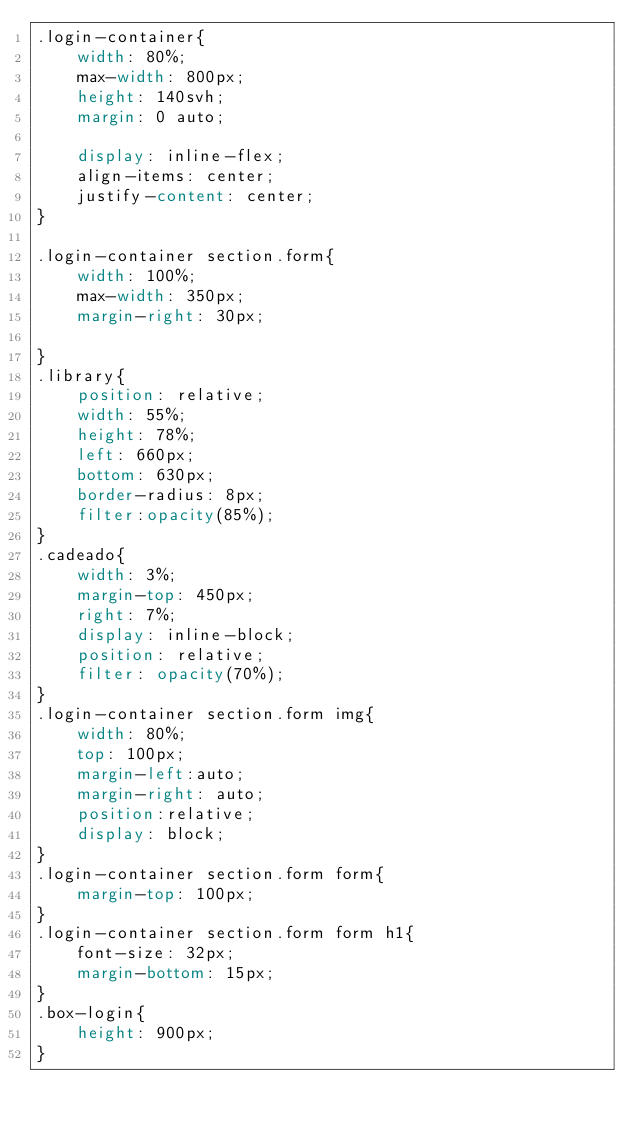<code> <loc_0><loc_0><loc_500><loc_500><_CSS_>.login-container{
    width: 80%;
    max-width: 800px;
    height: 140svh;
    margin: 0 auto;

    display: inline-flex;
    align-items: center;
    justify-content: center;
}

.login-container section.form{
    width: 100%;
    max-width: 350px;
    margin-right: 30px;

}
.library{
    position: relative;
    width: 55%;
    height: 78%;
    left: 660px;
    bottom: 630px;
    border-radius: 8px;
    filter:opacity(85%);
}
.cadeado{
    width: 3%;
    margin-top: 450px;
    right: 7%;
    display: inline-block;
    position: relative;
    filter: opacity(70%);
}
.login-container section.form img{
    width: 80%;
    top: 100px;
    margin-left:auto;
    margin-right: auto;
    position:relative;
    display: block;
}
.login-container section.form form{
    margin-top: 100px;
}
.login-container section.form form h1{
    font-size: 32px;
    margin-bottom: 15px;
}
.box-login{
    height: 900px;
}
</code> 